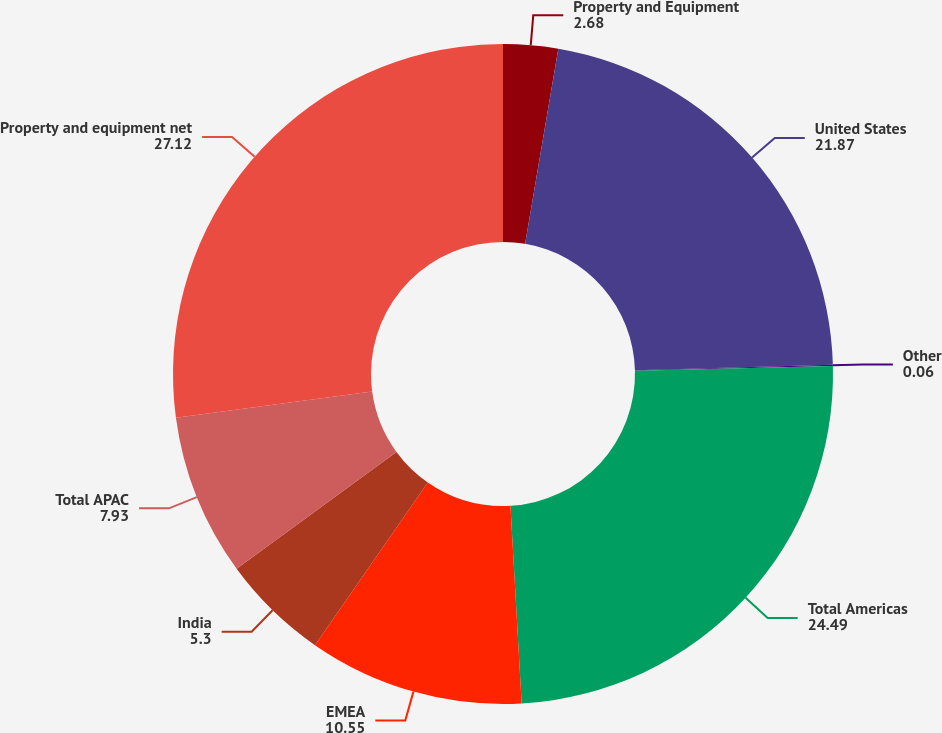Convert chart to OTSL. <chart><loc_0><loc_0><loc_500><loc_500><pie_chart><fcel>Property and Equipment<fcel>United States<fcel>Other<fcel>Total Americas<fcel>EMEA<fcel>India<fcel>Total APAC<fcel>Property and equipment net<nl><fcel>2.68%<fcel>21.87%<fcel>0.06%<fcel>24.49%<fcel>10.55%<fcel>5.3%<fcel>7.93%<fcel>27.12%<nl></chart> 